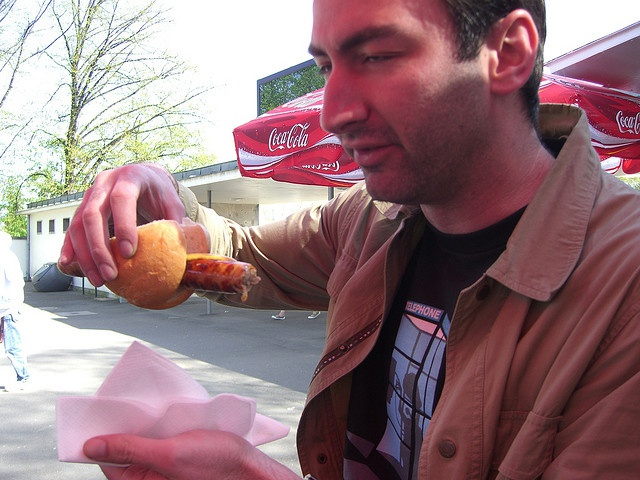Describe the objects in this image and their specific colors. I can see people in lightblue, maroon, black, and brown tones, umbrella in lightblue, brown, lavender, and maroon tones, and hot dog in lightblue, maroon, tan, and brown tones in this image. 